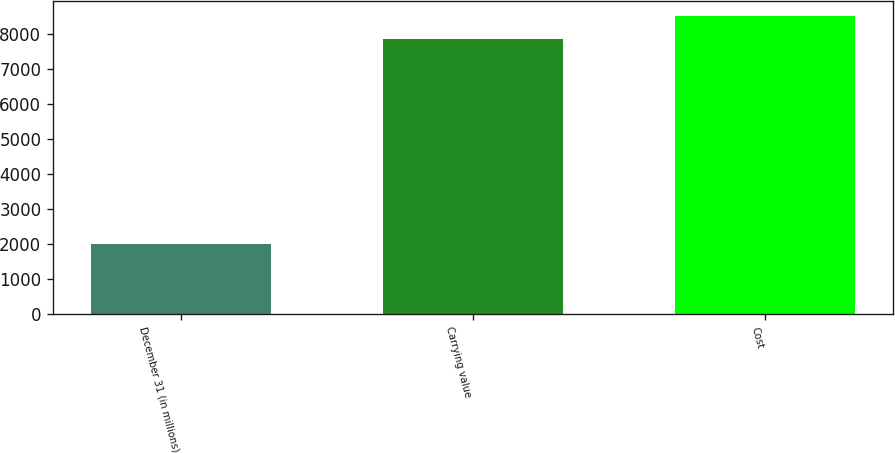Convert chart to OTSL. <chart><loc_0><loc_0><loc_500><loc_500><bar_chart><fcel>December 31 (in millions)<fcel>Carrying value<fcel>Cost<nl><fcel>2013<fcel>7868<fcel>8515.8<nl></chart> 